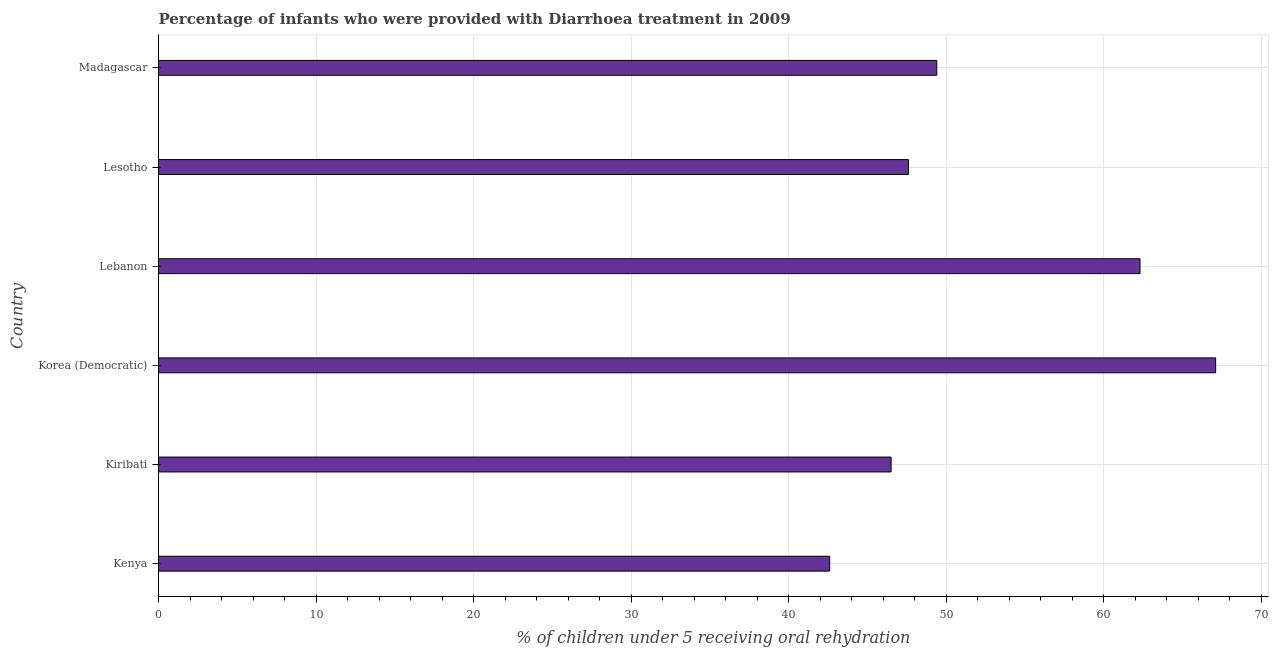Does the graph contain any zero values?
Provide a succinct answer. No. Does the graph contain grids?
Your answer should be very brief. Yes. What is the title of the graph?
Give a very brief answer. Percentage of infants who were provided with Diarrhoea treatment in 2009. What is the label or title of the X-axis?
Provide a succinct answer. % of children under 5 receiving oral rehydration. What is the percentage of children who were provided with treatment diarrhoea in Korea (Democratic)?
Give a very brief answer. 67.1. Across all countries, what is the maximum percentage of children who were provided with treatment diarrhoea?
Give a very brief answer. 67.1. Across all countries, what is the minimum percentage of children who were provided with treatment diarrhoea?
Provide a short and direct response. 42.6. In which country was the percentage of children who were provided with treatment diarrhoea maximum?
Provide a succinct answer. Korea (Democratic). In which country was the percentage of children who were provided with treatment diarrhoea minimum?
Provide a short and direct response. Kenya. What is the sum of the percentage of children who were provided with treatment diarrhoea?
Offer a terse response. 315.5. What is the difference between the percentage of children who were provided with treatment diarrhoea in Kenya and Korea (Democratic)?
Provide a succinct answer. -24.5. What is the average percentage of children who were provided with treatment diarrhoea per country?
Your answer should be very brief. 52.58. What is the median percentage of children who were provided with treatment diarrhoea?
Keep it short and to the point. 48.5. In how many countries, is the percentage of children who were provided with treatment diarrhoea greater than 12 %?
Offer a very short reply. 6. What is the ratio of the percentage of children who were provided with treatment diarrhoea in Korea (Democratic) to that in Madagascar?
Your answer should be compact. 1.36. What is the difference between the highest and the second highest percentage of children who were provided with treatment diarrhoea?
Offer a terse response. 4.8. Is the sum of the percentage of children who were provided with treatment diarrhoea in Lesotho and Madagascar greater than the maximum percentage of children who were provided with treatment diarrhoea across all countries?
Provide a succinct answer. Yes. What is the difference between the highest and the lowest percentage of children who were provided with treatment diarrhoea?
Make the answer very short. 24.5. How many bars are there?
Your response must be concise. 6. Are all the bars in the graph horizontal?
Make the answer very short. Yes. How many countries are there in the graph?
Your answer should be compact. 6. What is the difference between two consecutive major ticks on the X-axis?
Give a very brief answer. 10. What is the % of children under 5 receiving oral rehydration in Kenya?
Provide a succinct answer. 42.6. What is the % of children under 5 receiving oral rehydration in Kiribati?
Offer a very short reply. 46.5. What is the % of children under 5 receiving oral rehydration of Korea (Democratic)?
Ensure brevity in your answer.  67.1. What is the % of children under 5 receiving oral rehydration in Lebanon?
Your response must be concise. 62.3. What is the % of children under 5 receiving oral rehydration in Lesotho?
Your answer should be very brief. 47.6. What is the % of children under 5 receiving oral rehydration in Madagascar?
Your answer should be very brief. 49.4. What is the difference between the % of children under 5 receiving oral rehydration in Kenya and Kiribati?
Your answer should be very brief. -3.9. What is the difference between the % of children under 5 receiving oral rehydration in Kenya and Korea (Democratic)?
Provide a succinct answer. -24.5. What is the difference between the % of children under 5 receiving oral rehydration in Kenya and Lebanon?
Keep it short and to the point. -19.7. What is the difference between the % of children under 5 receiving oral rehydration in Kenya and Lesotho?
Your response must be concise. -5. What is the difference between the % of children under 5 receiving oral rehydration in Kiribati and Korea (Democratic)?
Your response must be concise. -20.6. What is the difference between the % of children under 5 receiving oral rehydration in Kiribati and Lebanon?
Offer a terse response. -15.8. What is the difference between the % of children under 5 receiving oral rehydration in Kiribati and Lesotho?
Ensure brevity in your answer.  -1.1. What is the difference between the % of children under 5 receiving oral rehydration in Kiribati and Madagascar?
Give a very brief answer. -2.9. What is the difference between the % of children under 5 receiving oral rehydration in Korea (Democratic) and Lebanon?
Provide a succinct answer. 4.8. What is the difference between the % of children under 5 receiving oral rehydration in Korea (Democratic) and Lesotho?
Give a very brief answer. 19.5. What is the difference between the % of children under 5 receiving oral rehydration in Korea (Democratic) and Madagascar?
Your response must be concise. 17.7. What is the ratio of the % of children under 5 receiving oral rehydration in Kenya to that in Kiribati?
Your response must be concise. 0.92. What is the ratio of the % of children under 5 receiving oral rehydration in Kenya to that in Korea (Democratic)?
Make the answer very short. 0.64. What is the ratio of the % of children under 5 receiving oral rehydration in Kenya to that in Lebanon?
Your answer should be compact. 0.68. What is the ratio of the % of children under 5 receiving oral rehydration in Kenya to that in Lesotho?
Your response must be concise. 0.9. What is the ratio of the % of children under 5 receiving oral rehydration in Kenya to that in Madagascar?
Offer a very short reply. 0.86. What is the ratio of the % of children under 5 receiving oral rehydration in Kiribati to that in Korea (Democratic)?
Keep it short and to the point. 0.69. What is the ratio of the % of children under 5 receiving oral rehydration in Kiribati to that in Lebanon?
Offer a terse response. 0.75. What is the ratio of the % of children under 5 receiving oral rehydration in Kiribati to that in Lesotho?
Give a very brief answer. 0.98. What is the ratio of the % of children under 5 receiving oral rehydration in Kiribati to that in Madagascar?
Ensure brevity in your answer.  0.94. What is the ratio of the % of children under 5 receiving oral rehydration in Korea (Democratic) to that in Lebanon?
Keep it short and to the point. 1.08. What is the ratio of the % of children under 5 receiving oral rehydration in Korea (Democratic) to that in Lesotho?
Keep it short and to the point. 1.41. What is the ratio of the % of children under 5 receiving oral rehydration in Korea (Democratic) to that in Madagascar?
Your answer should be compact. 1.36. What is the ratio of the % of children under 5 receiving oral rehydration in Lebanon to that in Lesotho?
Your response must be concise. 1.31. What is the ratio of the % of children under 5 receiving oral rehydration in Lebanon to that in Madagascar?
Offer a very short reply. 1.26. What is the ratio of the % of children under 5 receiving oral rehydration in Lesotho to that in Madagascar?
Give a very brief answer. 0.96. 